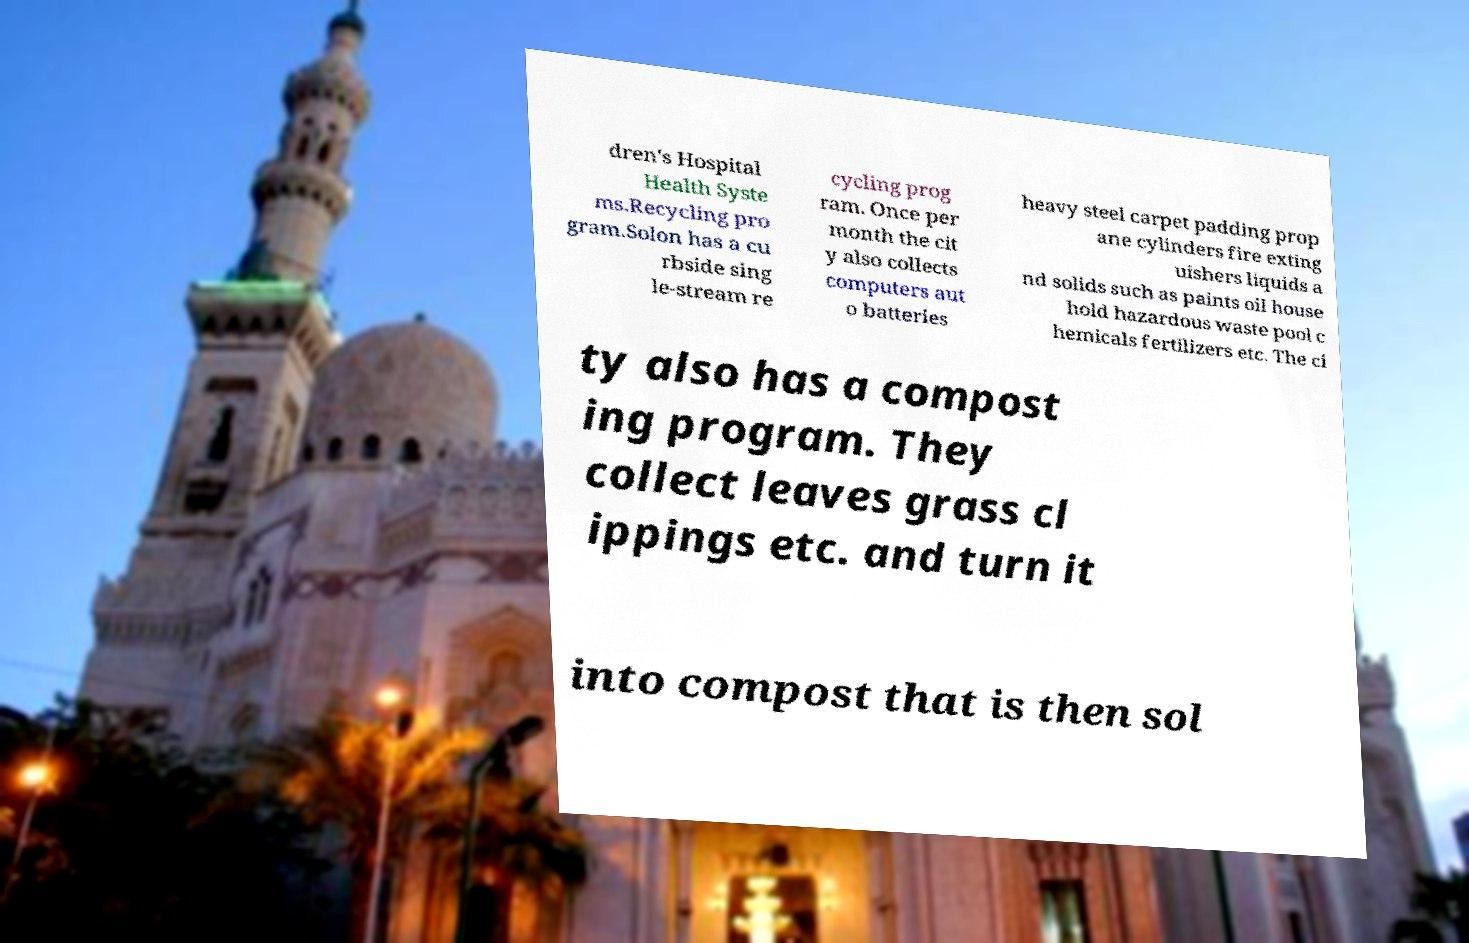Could you extract and type out the text from this image? dren's Hospital Health Syste ms.Recycling pro gram.Solon has a cu rbside sing le-stream re cycling prog ram. Once per month the cit y also collects computers aut o batteries heavy steel carpet padding prop ane cylinders fire exting uishers liquids a nd solids such as paints oil house hold hazardous waste pool c hemicals fertilizers etc. The ci ty also has a compost ing program. They collect leaves grass cl ippings etc. and turn it into compost that is then sol 